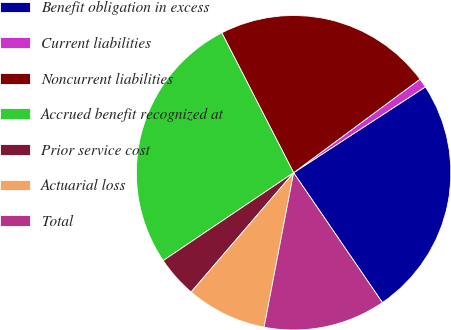<chart> <loc_0><loc_0><loc_500><loc_500><pie_chart><fcel>Benefit obligation in excess<fcel>Current liabilities<fcel>Noncurrent liabilities<fcel>Accrued benefit recognized at<fcel>Prior service cost<fcel>Actuarial loss<fcel>Total<nl><fcel>24.65%<fcel>0.95%<fcel>22.41%<fcel>26.89%<fcel>4.27%<fcel>8.29%<fcel>12.55%<nl></chart> 